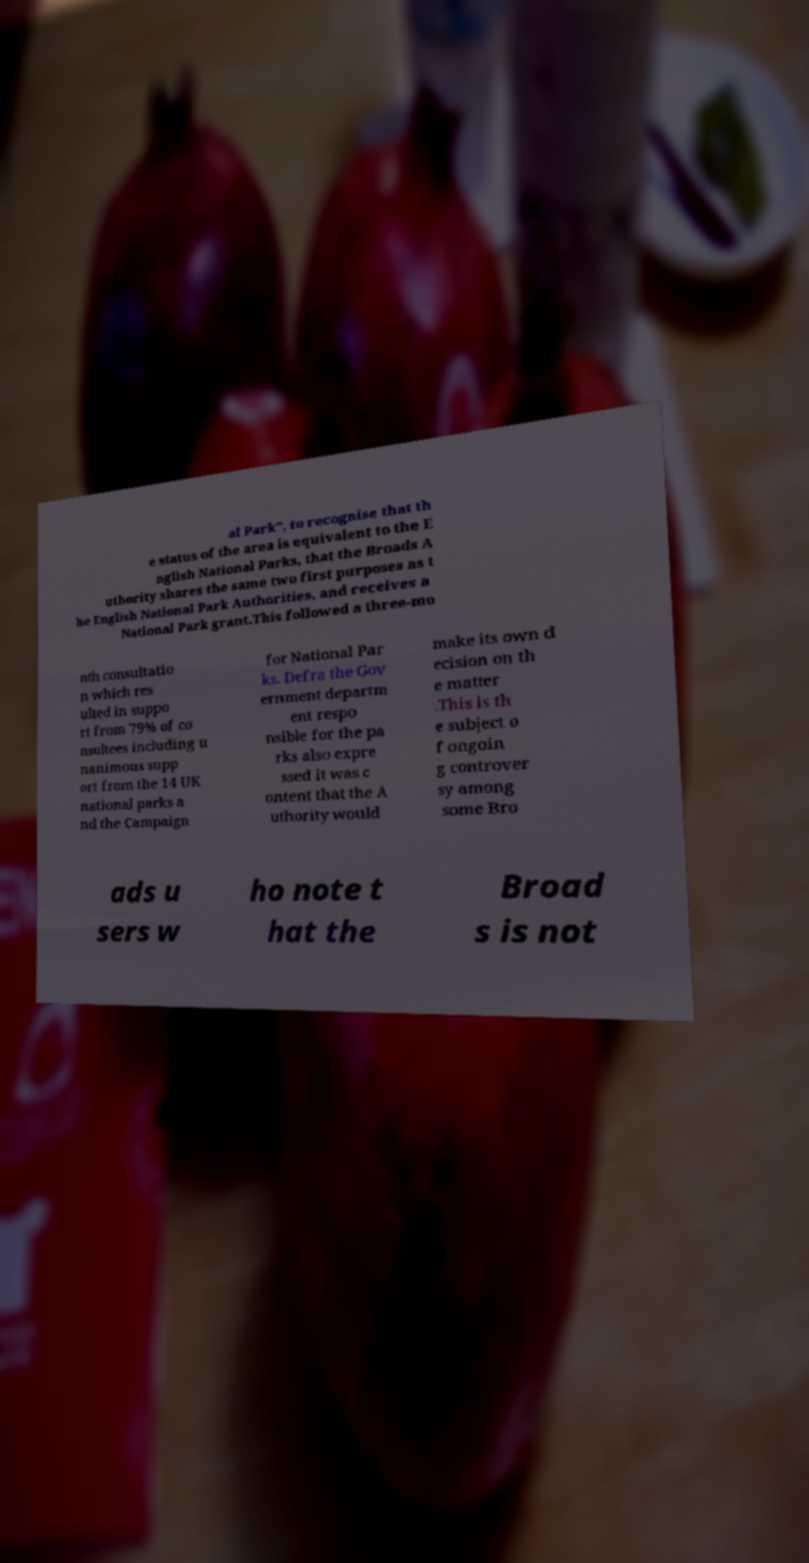For documentation purposes, I need the text within this image transcribed. Could you provide that? al Park", to recognise that th e status of the area is equivalent to the E nglish National Parks, that the Broads A uthority shares the same two first purposes as t he English National Park Authorities, and receives a National Park grant.This followed a three-mo nth consultatio n which res ulted in suppo rt from 79% of co nsultees including u nanimous supp ort from the 14 UK national parks a nd the Campaign for National Par ks. Defra the Gov ernment departm ent respo nsible for the pa rks also expre ssed it was c ontent that the A uthority would make its own d ecision on th e matter .This is th e subject o f ongoin g controver sy among some Bro ads u sers w ho note t hat the Broad s is not 